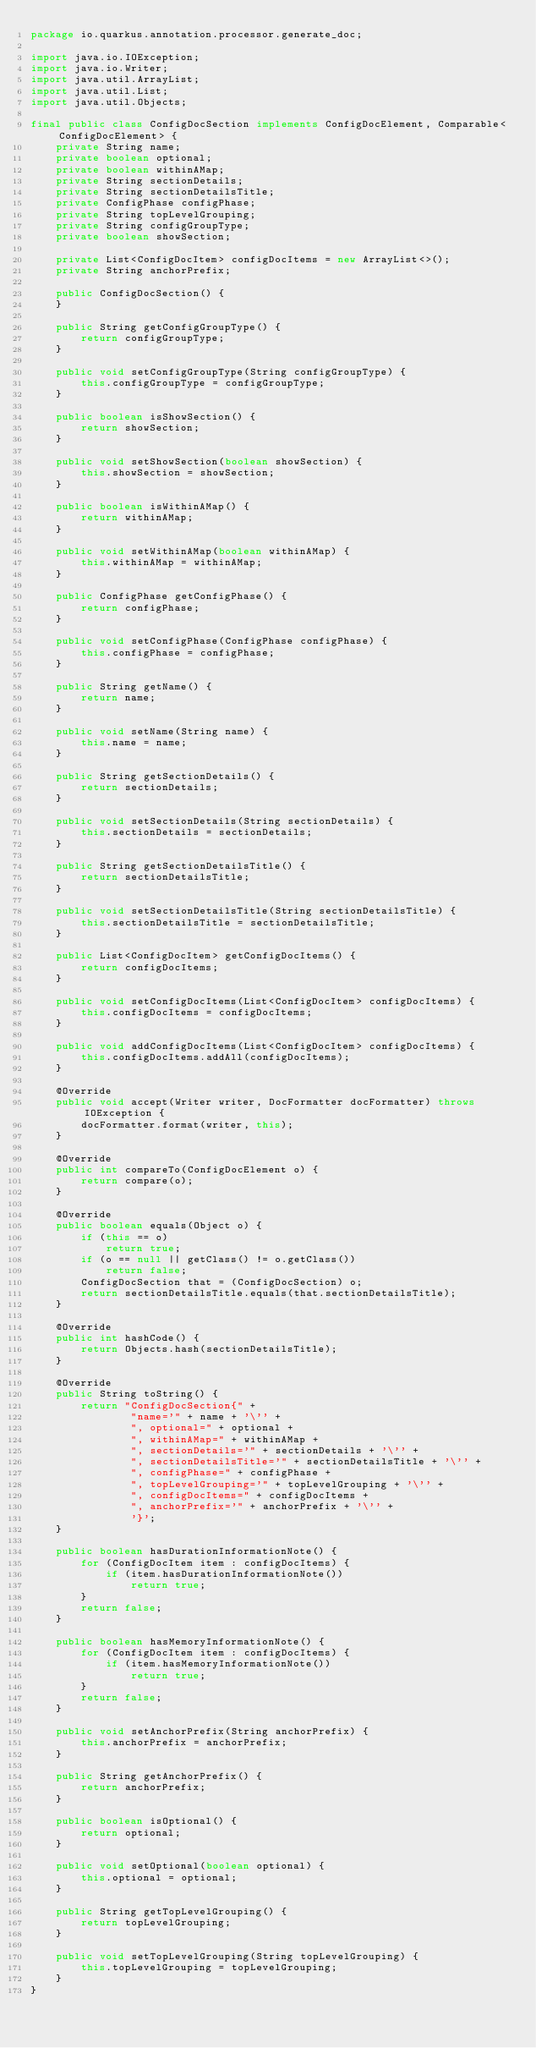<code> <loc_0><loc_0><loc_500><loc_500><_Java_>package io.quarkus.annotation.processor.generate_doc;

import java.io.IOException;
import java.io.Writer;
import java.util.ArrayList;
import java.util.List;
import java.util.Objects;

final public class ConfigDocSection implements ConfigDocElement, Comparable<ConfigDocElement> {
    private String name;
    private boolean optional;
    private boolean withinAMap;
    private String sectionDetails;
    private String sectionDetailsTitle;
    private ConfigPhase configPhase;
    private String topLevelGrouping;
    private String configGroupType;
    private boolean showSection;

    private List<ConfigDocItem> configDocItems = new ArrayList<>();
    private String anchorPrefix;

    public ConfigDocSection() {
    }

    public String getConfigGroupType() {
        return configGroupType;
    }

    public void setConfigGroupType(String configGroupType) {
        this.configGroupType = configGroupType;
    }

    public boolean isShowSection() {
        return showSection;
    }

    public void setShowSection(boolean showSection) {
        this.showSection = showSection;
    }

    public boolean isWithinAMap() {
        return withinAMap;
    }

    public void setWithinAMap(boolean withinAMap) {
        this.withinAMap = withinAMap;
    }

    public ConfigPhase getConfigPhase() {
        return configPhase;
    }

    public void setConfigPhase(ConfigPhase configPhase) {
        this.configPhase = configPhase;
    }

    public String getName() {
        return name;
    }

    public void setName(String name) {
        this.name = name;
    }

    public String getSectionDetails() {
        return sectionDetails;
    }

    public void setSectionDetails(String sectionDetails) {
        this.sectionDetails = sectionDetails;
    }

    public String getSectionDetailsTitle() {
        return sectionDetailsTitle;
    }

    public void setSectionDetailsTitle(String sectionDetailsTitle) {
        this.sectionDetailsTitle = sectionDetailsTitle;
    }

    public List<ConfigDocItem> getConfigDocItems() {
        return configDocItems;
    }

    public void setConfigDocItems(List<ConfigDocItem> configDocItems) {
        this.configDocItems = configDocItems;
    }

    public void addConfigDocItems(List<ConfigDocItem> configDocItems) {
        this.configDocItems.addAll(configDocItems);
    }

    @Override
    public void accept(Writer writer, DocFormatter docFormatter) throws IOException {
        docFormatter.format(writer, this);
    }

    @Override
    public int compareTo(ConfigDocElement o) {
        return compare(o);
    }

    @Override
    public boolean equals(Object o) {
        if (this == o)
            return true;
        if (o == null || getClass() != o.getClass())
            return false;
        ConfigDocSection that = (ConfigDocSection) o;
        return sectionDetailsTitle.equals(that.sectionDetailsTitle);
    }

    @Override
    public int hashCode() {
        return Objects.hash(sectionDetailsTitle);
    }

    @Override
    public String toString() {
        return "ConfigDocSection{" +
                "name='" + name + '\'' +
                ", optional=" + optional +
                ", withinAMap=" + withinAMap +
                ", sectionDetails='" + sectionDetails + '\'' +
                ", sectionDetailsTitle='" + sectionDetailsTitle + '\'' +
                ", configPhase=" + configPhase +
                ", topLevelGrouping='" + topLevelGrouping + '\'' +
                ", configDocItems=" + configDocItems +
                ", anchorPrefix='" + anchorPrefix + '\'' +
                '}';
    }

    public boolean hasDurationInformationNote() {
        for (ConfigDocItem item : configDocItems) {
            if (item.hasDurationInformationNote())
                return true;
        }
        return false;
    }

    public boolean hasMemoryInformationNote() {
        for (ConfigDocItem item : configDocItems) {
            if (item.hasMemoryInformationNote())
                return true;
        }
        return false;
    }

    public void setAnchorPrefix(String anchorPrefix) {
        this.anchorPrefix = anchorPrefix;
    }

    public String getAnchorPrefix() {
        return anchorPrefix;
    }

    public boolean isOptional() {
        return optional;
    }

    public void setOptional(boolean optional) {
        this.optional = optional;
    }

    public String getTopLevelGrouping() {
        return topLevelGrouping;
    }

    public void setTopLevelGrouping(String topLevelGrouping) {
        this.topLevelGrouping = topLevelGrouping;
    }
}
</code> 